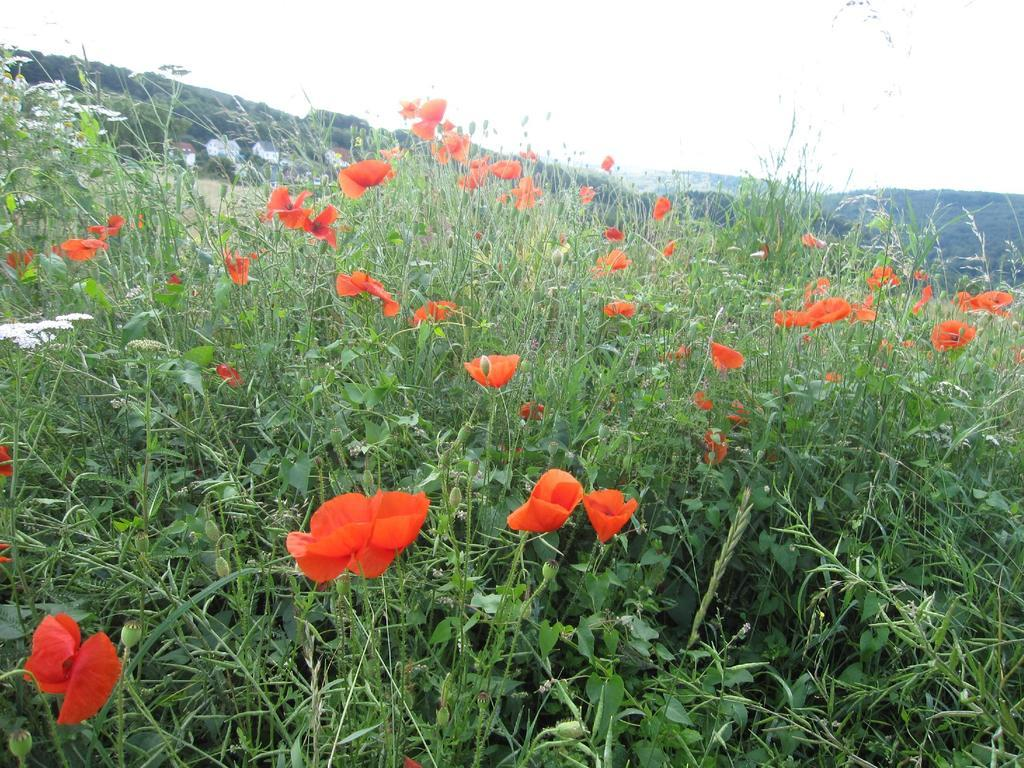What types of living organisms are in the foreground of the image? There are plants and flowers in the foreground of the image. What type of natural formation can be seen in the background of the image? There are mountains in the background of the image. What type of drawer can be seen in the image? There is no drawer present in the image. What type of vein is visible in the image? There is no vein visible in the image. 